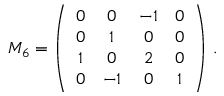Convert formula to latex. <formula><loc_0><loc_0><loc_500><loc_500>M _ { 6 } = \left ( \begin{array} { c c c c } { 0 } & { 0 } & { - 1 } & { 0 } \\ { 0 } & { 1 } & { 0 } & { 0 } \\ { 1 } & { 0 } & { 2 } & { 0 } \\ { 0 } & { - 1 } & { 0 } & { 1 } \end{array} \right ) \, .</formula> 